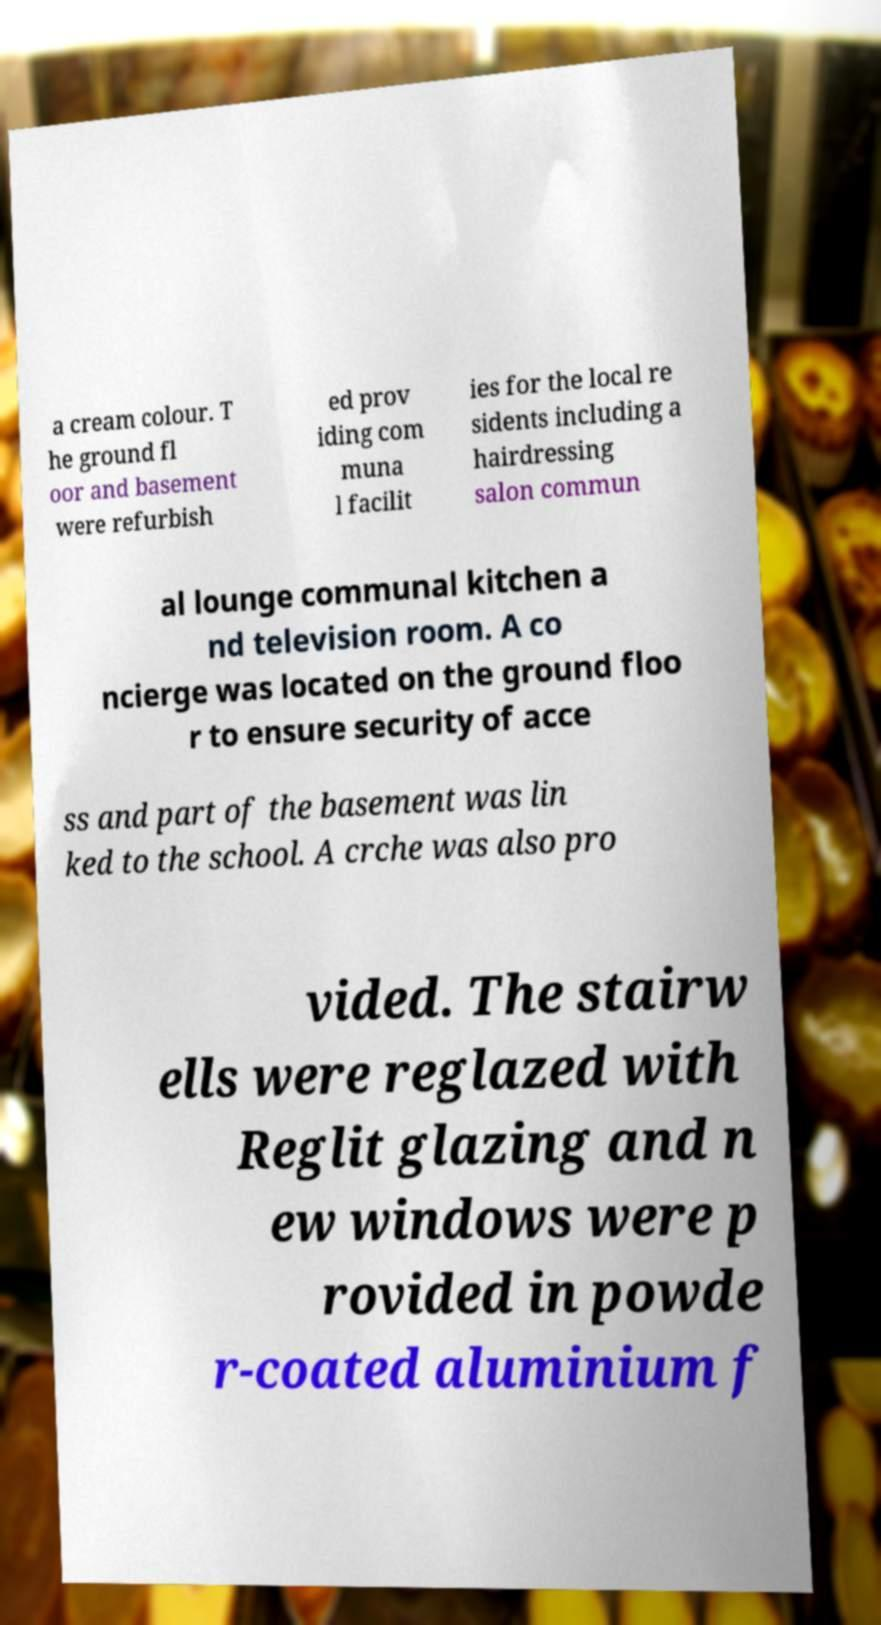Can you accurately transcribe the text from the provided image for me? a cream colour. T he ground fl oor and basement were refurbish ed prov iding com muna l facilit ies for the local re sidents including a hairdressing salon commun al lounge communal kitchen a nd television room. A co ncierge was located on the ground floo r to ensure security of acce ss and part of the basement was lin ked to the school. A crche was also pro vided. The stairw ells were reglazed with Reglit glazing and n ew windows were p rovided in powde r-coated aluminium f 